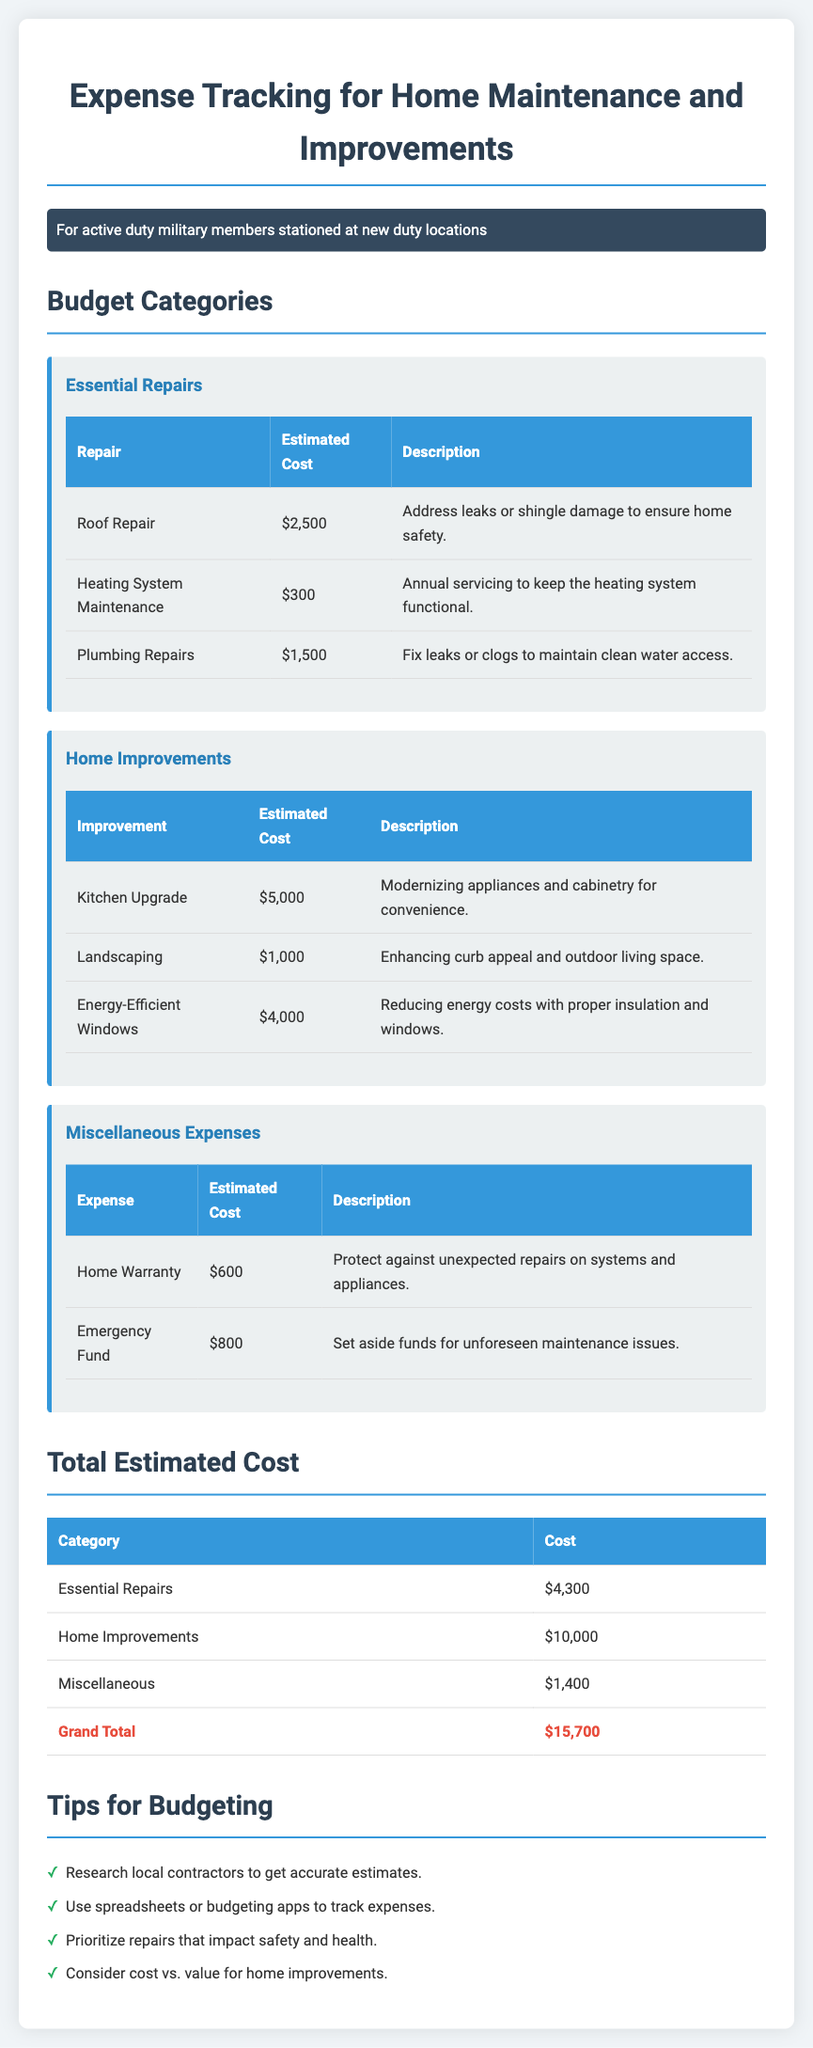what is the estimated cost for Roof Repair? The document states that the estimated cost for Roof Repair is $2,500.
Answer: $2,500 how much is allocated for the Kitchen Upgrade? The Kitchen Upgrade is listed with an estimated cost of $5,000.
Answer: $5,000 what is the total estimated cost for Essential Repairs? The document sums the costs for Essential Repairs to a total of $4,300.
Answer: $4,300 how many categories are listed under Budget Categories? The document lists three categories: Essential Repairs, Home Improvements, and Miscellaneous Expenses.
Answer: three what is the purpose of setting aside funds for an Emergency Fund? According to the document, the Emergency Fund is set aside for unforeseen maintenance issues.
Answer: unforeseen maintenance issues what is the grand total for all estimated costs? The document presents the grand total of all categories as $15,700.
Answer: $15,700 which improvement aims to reduce energy costs? The document states that Energy-Efficient Windows aim to reduce energy costs.
Answer: Energy-Efficient Windows how many estimates are provided under Miscellaneous Expenses? There are two estimates provided under the Miscellaneous Expenses category.
Answer: two what should be prioritized according to the budgeting tips? The tips suggest prioritizing repairs that impact safety and health.
Answer: safety and health 